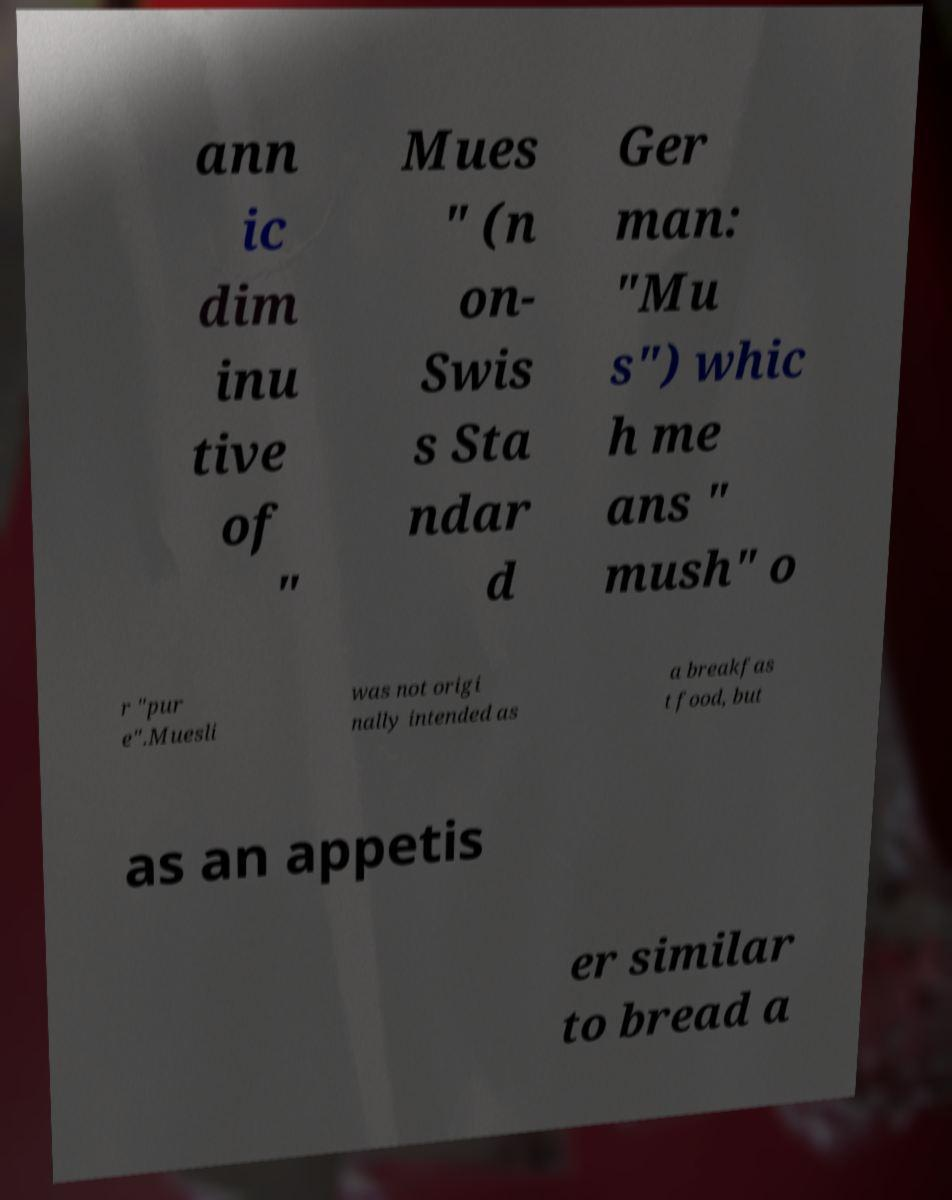Please read and relay the text visible in this image. What does it say? ann ic dim inu tive of " Mues " (n on- Swis s Sta ndar d Ger man: "Mu s") whic h me ans " mush" o r "pur e".Muesli was not origi nally intended as a breakfas t food, but as an appetis er similar to bread a 